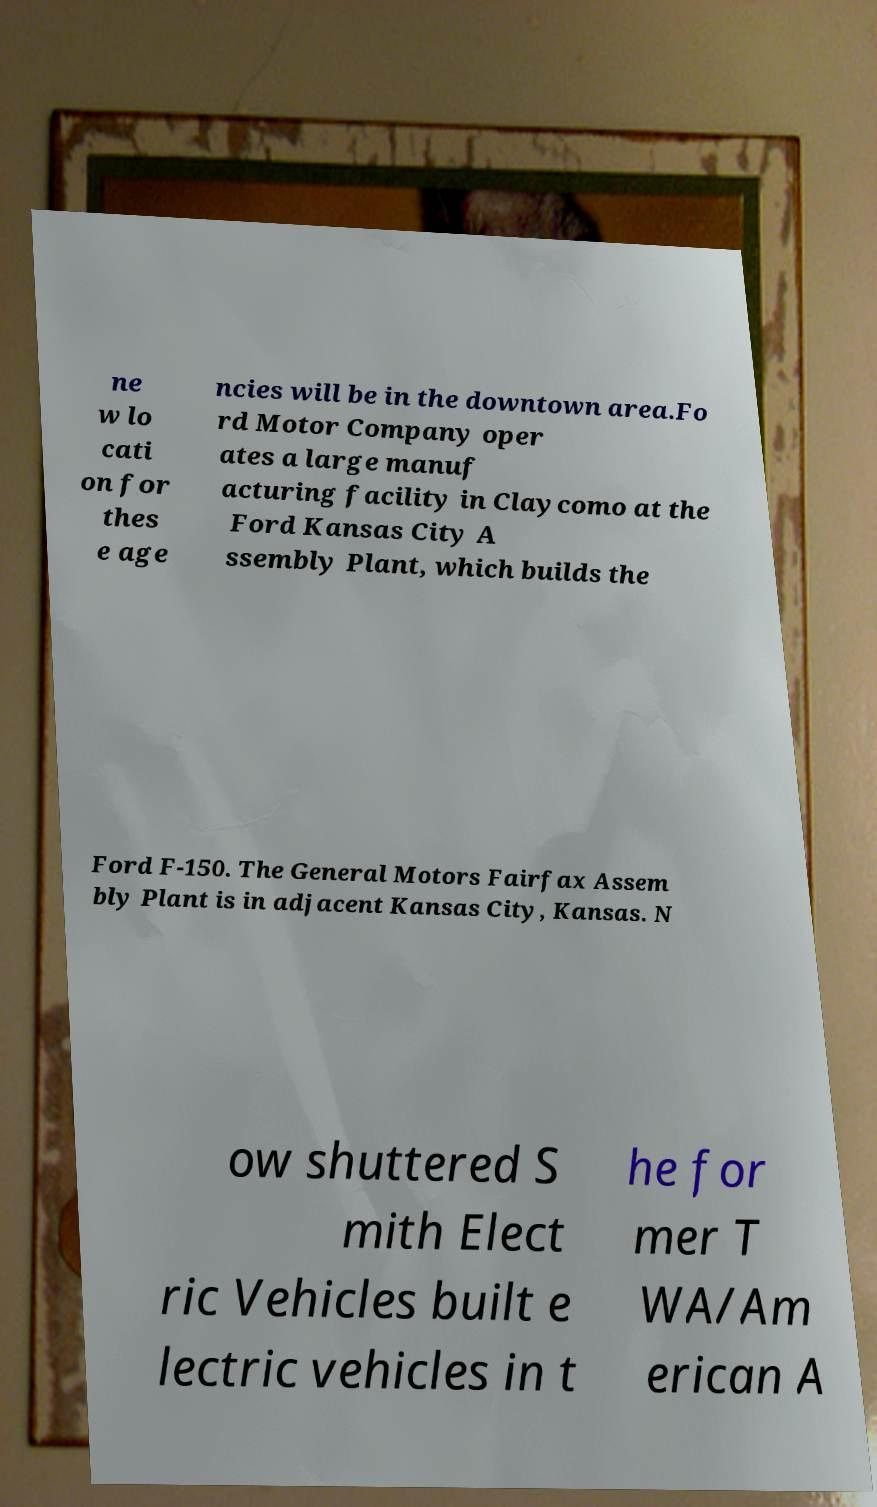Can you read and provide the text displayed in the image?This photo seems to have some interesting text. Can you extract and type it out for me? ne w lo cati on for thes e age ncies will be in the downtown area.Fo rd Motor Company oper ates a large manuf acturing facility in Claycomo at the Ford Kansas City A ssembly Plant, which builds the Ford F-150. The General Motors Fairfax Assem bly Plant is in adjacent Kansas City, Kansas. N ow shuttered S mith Elect ric Vehicles built e lectric vehicles in t he for mer T WA/Am erican A 